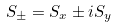<formula> <loc_0><loc_0><loc_500><loc_500>S _ { \pm } = S _ { x } \pm i S _ { y }</formula> 